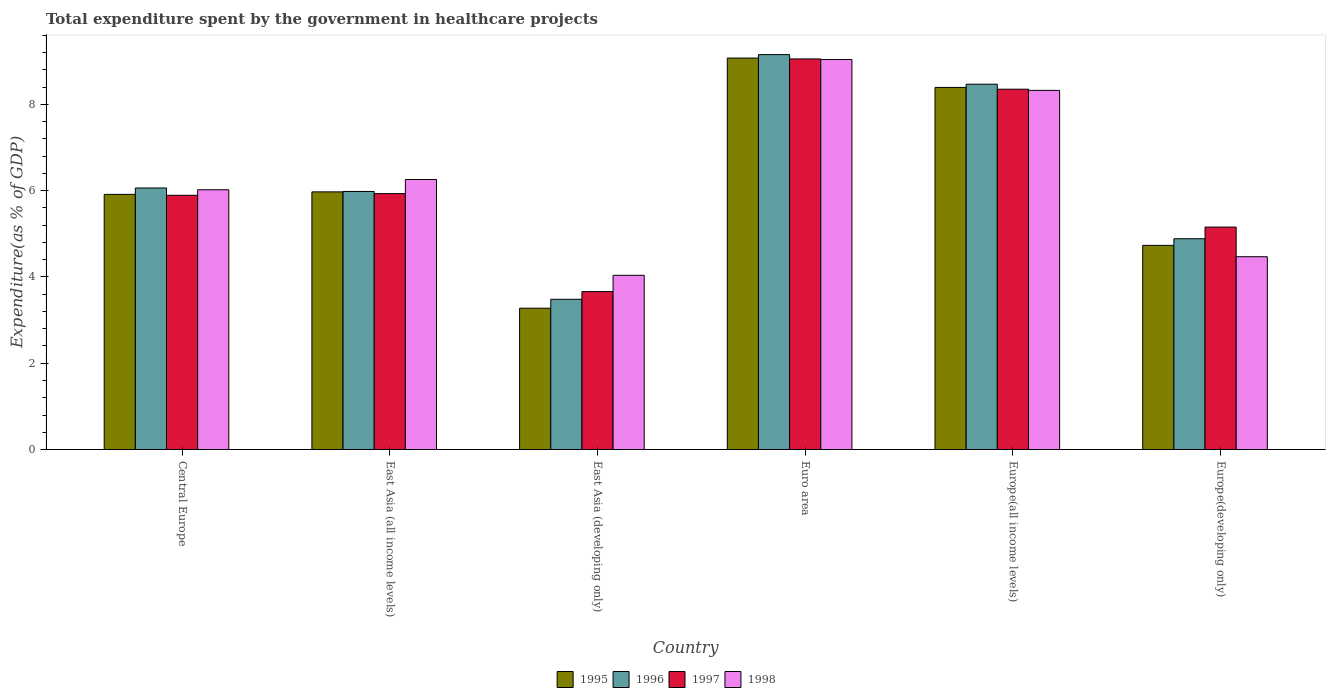Are the number of bars per tick equal to the number of legend labels?
Offer a very short reply. Yes. How many bars are there on the 3rd tick from the right?
Offer a very short reply. 4. What is the label of the 2nd group of bars from the left?
Offer a terse response. East Asia (all income levels). In how many cases, is the number of bars for a given country not equal to the number of legend labels?
Provide a succinct answer. 0. What is the total expenditure spent by the government in healthcare projects in 1995 in East Asia (all income levels)?
Offer a very short reply. 5.97. Across all countries, what is the maximum total expenditure spent by the government in healthcare projects in 1995?
Offer a very short reply. 9.08. Across all countries, what is the minimum total expenditure spent by the government in healthcare projects in 1998?
Offer a terse response. 4.04. In which country was the total expenditure spent by the government in healthcare projects in 1995 maximum?
Keep it short and to the point. Euro area. In which country was the total expenditure spent by the government in healthcare projects in 1996 minimum?
Provide a short and direct response. East Asia (developing only). What is the total total expenditure spent by the government in healthcare projects in 1998 in the graph?
Your answer should be compact. 38.16. What is the difference between the total expenditure spent by the government in healthcare projects in 1998 in Central Europe and that in Europe(developing only)?
Your answer should be compact. 1.55. What is the difference between the total expenditure spent by the government in healthcare projects in 1996 in East Asia (developing only) and the total expenditure spent by the government in healthcare projects in 1995 in East Asia (all income levels)?
Ensure brevity in your answer.  -2.49. What is the average total expenditure spent by the government in healthcare projects in 1995 per country?
Give a very brief answer. 6.23. What is the difference between the total expenditure spent by the government in healthcare projects of/in 1995 and total expenditure spent by the government in healthcare projects of/in 1997 in Euro area?
Keep it short and to the point. 0.02. What is the ratio of the total expenditure spent by the government in healthcare projects in 1996 in Central Europe to that in East Asia (all income levels)?
Keep it short and to the point. 1.01. What is the difference between the highest and the second highest total expenditure spent by the government in healthcare projects in 1996?
Give a very brief answer. -0.69. What is the difference between the highest and the lowest total expenditure spent by the government in healthcare projects in 1996?
Your response must be concise. 5.67. Is the sum of the total expenditure spent by the government in healthcare projects in 1998 in Euro area and Europe(developing only) greater than the maximum total expenditure spent by the government in healthcare projects in 1995 across all countries?
Provide a succinct answer. Yes. What does the 2nd bar from the left in East Asia (all income levels) represents?
Provide a short and direct response. 1996. What does the 3rd bar from the right in Euro area represents?
Provide a succinct answer. 1996. How many bars are there?
Keep it short and to the point. 24. Are all the bars in the graph horizontal?
Your response must be concise. No. What is the difference between two consecutive major ticks on the Y-axis?
Make the answer very short. 2. Does the graph contain grids?
Your answer should be compact. No. How many legend labels are there?
Your answer should be compact. 4. How are the legend labels stacked?
Your response must be concise. Horizontal. What is the title of the graph?
Ensure brevity in your answer.  Total expenditure spent by the government in healthcare projects. Does "1983" appear as one of the legend labels in the graph?
Offer a terse response. No. What is the label or title of the Y-axis?
Offer a terse response. Expenditure(as % of GDP). What is the Expenditure(as % of GDP) in 1995 in Central Europe?
Offer a very short reply. 5.92. What is the Expenditure(as % of GDP) of 1996 in Central Europe?
Offer a very short reply. 6.06. What is the Expenditure(as % of GDP) of 1997 in Central Europe?
Your answer should be compact. 5.89. What is the Expenditure(as % of GDP) of 1998 in Central Europe?
Make the answer very short. 6.02. What is the Expenditure(as % of GDP) of 1995 in East Asia (all income levels)?
Offer a terse response. 5.97. What is the Expenditure(as % of GDP) of 1996 in East Asia (all income levels)?
Give a very brief answer. 5.98. What is the Expenditure(as % of GDP) of 1997 in East Asia (all income levels)?
Your answer should be very brief. 5.93. What is the Expenditure(as % of GDP) in 1998 in East Asia (all income levels)?
Give a very brief answer. 6.26. What is the Expenditure(as % of GDP) in 1995 in East Asia (developing only)?
Provide a succinct answer. 3.28. What is the Expenditure(as % of GDP) of 1996 in East Asia (developing only)?
Provide a succinct answer. 3.48. What is the Expenditure(as % of GDP) of 1997 in East Asia (developing only)?
Offer a very short reply. 3.66. What is the Expenditure(as % of GDP) in 1998 in East Asia (developing only)?
Your answer should be very brief. 4.04. What is the Expenditure(as % of GDP) in 1995 in Euro area?
Make the answer very short. 9.08. What is the Expenditure(as % of GDP) of 1996 in Euro area?
Make the answer very short. 9.16. What is the Expenditure(as % of GDP) in 1997 in Euro area?
Provide a short and direct response. 9.06. What is the Expenditure(as % of GDP) in 1998 in Euro area?
Your answer should be compact. 9.04. What is the Expenditure(as % of GDP) of 1995 in Europe(all income levels)?
Your response must be concise. 8.39. What is the Expenditure(as % of GDP) in 1996 in Europe(all income levels)?
Offer a terse response. 8.47. What is the Expenditure(as % of GDP) in 1997 in Europe(all income levels)?
Your answer should be compact. 8.35. What is the Expenditure(as % of GDP) in 1998 in Europe(all income levels)?
Provide a short and direct response. 8.33. What is the Expenditure(as % of GDP) of 1995 in Europe(developing only)?
Ensure brevity in your answer.  4.73. What is the Expenditure(as % of GDP) in 1996 in Europe(developing only)?
Keep it short and to the point. 4.89. What is the Expenditure(as % of GDP) of 1997 in Europe(developing only)?
Make the answer very short. 5.16. What is the Expenditure(as % of GDP) of 1998 in Europe(developing only)?
Your response must be concise. 4.47. Across all countries, what is the maximum Expenditure(as % of GDP) in 1995?
Your answer should be very brief. 9.08. Across all countries, what is the maximum Expenditure(as % of GDP) in 1996?
Ensure brevity in your answer.  9.16. Across all countries, what is the maximum Expenditure(as % of GDP) in 1997?
Ensure brevity in your answer.  9.06. Across all countries, what is the maximum Expenditure(as % of GDP) of 1998?
Your response must be concise. 9.04. Across all countries, what is the minimum Expenditure(as % of GDP) in 1995?
Your answer should be compact. 3.28. Across all countries, what is the minimum Expenditure(as % of GDP) in 1996?
Keep it short and to the point. 3.48. Across all countries, what is the minimum Expenditure(as % of GDP) in 1997?
Your response must be concise. 3.66. Across all countries, what is the minimum Expenditure(as % of GDP) in 1998?
Your answer should be very brief. 4.04. What is the total Expenditure(as % of GDP) in 1995 in the graph?
Offer a very short reply. 37.37. What is the total Expenditure(as % of GDP) of 1996 in the graph?
Offer a terse response. 38.04. What is the total Expenditure(as % of GDP) in 1997 in the graph?
Your answer should be very brief. 38.05. What is the total Expenditure(as % of GDP) in 1998 in the graph?
Your answer should be compact. 38.16. What is the difference between the Expenditure(as % of GDP) of 1995 in Central Europe and that in East Asia (all income levels)?
Give a very brief answer. -0.06. What is the difference between the Expenditure(as % of GDP) in 1996 in Central Europe and that in East Asia (all income levels)?
Ensure brevity in your answer.  0.08. What is the difference between the Expenditure(as % of GDP) in 1997 in Central Europe and that in East Asia (all income levels)?
Offer a terse response. -0.04. What is the difference between the Expenditure(as % of GDP) in 1998 in Central Europe and that in East Asia (all income levels)?
Provide a succinct answer. -0.24. What is the difference between the Expenditure(as % of GDP) of 1995 in Central Europe and that in East Asia (developing only)?
Provide a short and direct response. 2.64. What is the difference between the Expenditure(as % of GDP) of 1996 in Central Europe and that in East Asia (developing only)?
Your answer should be compact. 2.58. What is the difference between the Expenditure(as % of GDP) in 1997 in Central Europe and that in East Asia (developing only)?
Offer a very short reply. 2.23. What is the difference between the Expenditure(as % of GDP) in 1998 in Central Europe and that in East Asia (developing only)?
Give a very brief answer. 1.98. What is the difference between the Expenditure(as % of GDP) in 1995 in Central Europe and that in Euro area?
Make the answer very short. -3.16. What is the difference between the Expenditure(as % of GDP) of 1996 in Central Europe and that in Euro area?
Your answer should be very brief. -3.09. What is the difference between the Expenditure(as % of GDP) of 1997 in Central Europe and that in Euro area?
Provide a succinct answer. -3.16. What is the difference between the Expenditure(as % of GDP) of 1998 in Central Europe and that in Euro area?
Make the answer very short. -3.02. What is the difference between the Expenditure(as % of GDP) in 1995 in Central Europe and that in Europe(all income levels)?
Make the answer very short. -2.48. What is the difference between the Expenditure(as % of GDP) in 1996 in Central Europe and that in Europe(all income levels)?
Offer a very short reply. -2.41. What is the difference between the Expenditure(as % of GDP) in 1997 in Central Europe and that in Europe(all income levels)?
Your response must be concise. -2.46. What is the difference between the Expenditure(as % of GDP) in 1998 in Central Europe and that in Europe(all income levels)?
Offer a very short reply. -2.3. What is the difference between the Expenditure(as % of GDP) in 1995 in Central Europe and that in Europe(developing only)?
Your response must be concise. 1.18. What is the difference between the Expenditure(as % of GDP) of 1996 in Central Europe and that in Europe(developing only)?
Offer a terse response. 1.18. What is the difference between the Expenditure(as % of GDP) of 1997 in Central Europe and that in Europe(developing only)?
Give a very brief answer. 0.74. What is the difference between the Expenditure(as % of GDP) of 1998 in Central Europe and that in Europe(developing only)?
Your answer should be very brief. 1.55. What is the difference between the Expenditure(as % of GDP) of 1995 in East Asia (all income levels) and that in East Asia (developing only)?
Your answer should be compact. 2.7. What is the difference between the Expenditure(as % of GDP) of 1996 in East Asia (all income levels) and that in East Asia (developing only)?
Offer a terse response. 2.5. What is the difference between the Expenditure(as % of GDP) in 1997 in East Asia (all income levels) and that in East Asia (developing only)?
Offer a terse response. 2.27. What is the difference between the Expenditure(as % of GDP) of 1998 in East Asia (all income levels) and that in East Asia (developing only)?
Ensure brevity in your answer.  2.22. What is the difference between the Expenditure(as % of GDP) of 1995 in East Asia (all income levels) and that in Euro area?
Your response must be concise. -3.1. What is the difference between the Expenditure(as % of GDP) of 1996 in East Asia (all income levels) and that in Euro area?
Offer a terse response. -3.17. What is the difference between the Expenditure(as % of GDP) of 1997 in East Asia (all income levels) and that in Euro area?
Ensure brevity in your answer.  -3.12. What is the difference between the Expenditure(as % of GDP) in 1998 in East Asia (all income levels) and that in Euro area?
Provide a short and direct response. -2.78. What is the difference between the Expenditure(as % of GDP) of 1995 in East Asia (all income levels) and that in Europe(all income levels)?
Offer a very short reply. -2.42. What is the difference between the Expenditure(as % of GDP) of 1996 in East Asia (all income levels) and that in Europe(all income levels)?
Offer a terse response. -2.49. What is the difference between the Expenditure(as % of GDP) in 1997 in East Asia (all income levels) and that in Europe(all income levels)?
Your answer should be compact. -2.42. What is the difference between the Expenditure(as % of GDP) of 1998 in East Asia (all income levels) and that in Europe(all income levels)?
Provide a succinct answer. -2.07. What is the difference between the Expenditure(as % of GDP) of 1995 in East Asia (all income levels) and that in Europe(developing only)?
Make the answer very short. 1.24. What is the difference between the Expenditure(as % of GDP) in 1996 in East Asia (all income levels) and that in Europe(developing only)?
Keep it short and to the point. 1.1. What is the difference between the Expenditure(as % of GDP) of 1997 in East Asia (all income levels) and that in Europe(developing only)?
Make the answer very short. 0.78. What is the difference between the Expenditure(as % of GDP) of 1998 in East Asia (all income levels) and that in Europe(developing only)?
Give a very brief answer. 1.79. What is the difference between the Expenditure(as % of GDP) in 1995 in East Asia (developing only) and that in Euro area?
Provide a short and direct response. -5.8. What is the difference between the Expenditure(as % of GDP) of 1996 in East Asia (developing only) and that in Euro area?
Give a very brief answer. -5.67. What is the difference between the Expenditure(as % of GDP) of 1997 in East Asia (developing only) and that in Euro area?
Ensure brevity in your answer.  -5.39. What is the difference between the Expenditure(as % of GDP) of 1998 in East Asia (developing only) and that in Euro area?
Your answer should be very brief. -5. What is the difference between the Expenditure(as % of GDP) in 1995 in East Asia (developing only) and that in Europe(all income levels)?
Provide a succinct answer. -5.12. What is the difference between the Expenditure(as % of GDP) of 1996 in East Asia (developing only) and that in Europe(all income levels)?
Make the answer very short. -4.99. What is the difference between the Expenditure(as % of GDP) of 1997 in East Asia (developing only) and that in Europe(all income levels)?
Provide a short and direct response. -4.69. What is the difference between the Expenditure(as % of GDP) of 1998 in East Asia (developing only) and that in Europe(all income levels)?
Offer a very short reply. -4.29. What is the difference between the Expenditure(as % of GDP) in 1995 in East Asia (developing only) and that in Europe(developing only)?
Give a very brief answer. -1.46. What is the difference between the Expenditure(as % of GDP) in 1996 in East Asia (developing only) and that in Europe(developing only)?
Your answer should be compact. -1.4. What is the difference between the Expenditure(as % of GDP) in 1997 in East Asia (developing only) and that in Europe(developing only)?
Offer a terse response. -1.5. What is the difference between the Expenditure(as % of GDP) of 1998 in East Asia (developing only) and that in Europe(developing only)?
Provide a succinct answer. -0.43. What is the difference between the Expenditure(as % of GDP) in 1995 in Euro area and that in Europe(all income levels)?
Offer a very short reply. 0.68. What is the difference between the Expenditure(as % of GDP) in 1996 in Euro area and that in Europe(all income levels)?
Ensure brevity in your answer.  0.69. What is the difference between the Expenditure(as % of GDP) of 1997 in Euro area and that in Europe(all income levels)?
Ensure brevity in your answer.  0.7. What is the difference between the Expenditure(as % of GDP) in 1998 in Euro area and that in Europe(all income levels)?
Offer a very short reply. 0.72. What is the difference between the Expenditure(as % of GDP) of 1995 in Euro area and that in Europe(developing only)?
Your answer should be very brief. 4.34. What is the difference between the Expenditure(as % of GDP) of 1996 in Euro area and that in Europe(developing only)?
Provide a short and direct response. 4.27. What is the difference between the Expenditure(as % of GDP) of 1997 in Euro area and that in Europe(developing only)?
Your answer should be very brief. 3.9. What is the difference between the Expenditure(as % of GDP) in 1998 in Euro area and that in Europe(developing only)?
Keep it short and to the point. 4.57. What is the difference between the Expenditure(as % of GDP) of 1995 in Europe(all income levels) and that in Europe(developing only)?
Give a very brief answer. 3.66. What is the difference between the Expenditure(as % of GDP) in 1996 in Europe(all income levels) and that in Europe(developing only)?
Your answer should be very brief. 3.58. What is the difference between the Expenditure(as % of GDP) of 1997 in Europe(all income levels) and that in Europe(developing only)?
Your answer should be compact. 3.2. What is the difference between the Expenditure(as % of GDP) of 1998 in Europe(all income levels) and that in Europe(developing only)?
Your answer should be compact. 3.86. What is the difference between the Expenditure(as % of GDP) of 1995 in Central Europe and the Expenditure(as % of GDP) of 1996 in East Asia (all income levels)?
Provide a succinct answer. -0.07. What is the difference between the Expenditure(as % of GDP) in 1995 in Central Europe and the Expenditure(as % of GDP) in 1997 in East Asia (all income levels)?
Offer a very short reply. -0.02. What is the difference between the Expenditure(as % of GDP) in 1995 in Central Europe and the Expenditure(as % of GDP) in 1998 in East Asia (all income levels)?
Offer a terse response. -0.34. What is the difference between the Expenditure(as % of GDP) in 1996 in Central Europe and the Expenditure(as % of GDP) in 1997 in East Asia (all income levels)?
Your answer should be compact. 0.13. What is the difference between the Expenditure(as % of GDP) of 1996 in Central Europe and the Expenditure(as % of GDP) of 1998 in East Asia (all income levels)?
Provide a short and direct response. -0.2. What is the difference between the Expenditure(as % of GDP) in 1997 in Central Europe and the Expenditure(as % of GDP) in 1998 in East Asia (all income levels)?
Offer a very short reply. -0.37. What is the difference between the Expenditure(as % of GDP) in 1995 in Central Europe and the Expenditure(as % of GDP) in 1996 in East Asia (developing only)?
Make the answer very short. 2.43. What is the difference between the Expenditure(as % of GDP) of 1995 in Central Europe and the Expenditure(as % of GDP) of 1997 in East Asia (developing only)?
Keep it short and to the point. 2.25. What is the difference between the Expenditure(as % of GDP) of 1995 in Central Europe and the Expenditure(as % of GDP) of 1998 in East Asia (developing only)?
Your response must be concise. 1.88. What is the difference between the Expenditure(as % of GDP) in 1996 in Central Europe and the Expenditure(as % of GDP) in 1997 in East Asia (developing only)?
Your answer should be very brief. 2.4. What is the difference between the Expenditure(as % of GDP) in 1996 in Central Europe and the Expenditure(as % of GDP) in 1998 in East Asia (developing only)?
Keep it short and to the point. 2.02. What is the difference between the Expenditure(as % of GDP) in 1997 in Central Europe and the Expenditure(as % of GDP) in 1998 in East Asia (developing only)?
Make the answer very short. 1.86. What is the difference between the Expenditure(as % of GDP) in 1995 in Central Europe and the Expenditure(as % of GDP) in 1996 in Euro area?
Your answer should be compact. -3.24. What is the difference between the Expenditure(as % of GDP) of 1995 in Central Europe and the Expenditure(as % of GDP) of 1997 in Euro area?
Provide a succinct answer. -3.14. What is the difference between the Expenditure(as % of GDP) in 1995 in Central Europe and the Expenditure(as % of GDP) in 1998 in Euro area?
Provide a short and direct response. -3.13. What is the difference between the Expenditure(as % of GDP) of 1996 in Central Europe and the Expenditure(as % of GDP) of 1997 in Euro area?
Your answer should be very brief. -2.99. What is the difference between the Expenditure(as % of GDP) of 1996 in Central Europe and the Expenditure(as % of GDP) of 1998 in Euro area?
Your answer should be compact. -2.98. What is the difference between the Expenditure(as % of GDP) in 1997 in Central Europe and the Expenditure(as % of GDP) in 1998 in Euro area?
Provide a short and direct response. -3.15. What is the difference between the Expenditure(as % of GDP) in 1995 in Central Europe and the Expenditure(as % of GDP) in 1996 in Europe(all income levels)?
Ensure brevity in your answer.  -2.55. What is the difference between the Expenditure(as % of GDP) of 1995 in Central Europe and the Expenditure(as % of GDP) of 1997 in Europe(all income levels)?
Provide a short and direct response. -2.44. What is the difference between the Expenditure(as % of GDP) in 1995 in Central Europe and the Expenditure(as % of GDP) in 1998 in Europe(all income levels)?
Ensure brevity in your answer.  -2.41. What is the difference between the Expenditure(as % of GDP) in 1996 in Central Europe and the Expenditure(as % of GDP) in 1997 in Europe(all income levels)?
Your answer should be compact. -2.29. What is the difference between the Expenditure(as % of GDP) of 1996 in Central Europe and the Expenditure(as % of GDP) of 1998 in Europe(all income levels)?
Make the answer very short. -2.26. What is the difference between the Expenditure(as % of GDP) of 1997 in Central Europe and the Expenditure(as % of GDP) of 1998 in Europe(all income levels)?
Keep it short and to the point. -2.43. What is the difference between the Expenditure(as % of GDP) in 1995 in Central Europe and the Expenditure(as % of GDP) in 1996 in Europe(developing only)?
Keep it short and to the point. 1.03. What is the difference between the Expenditure(as % of GDP) in 1995 in Central Europe and the Expenditure(as % of GDP) in 1997 in Europe(developing only)?
Keep it short and to the point. 0.76. What is the difference between the Expenditure(as % of GDP) of 1995 in Central Europe and the Expenditure(as % of GDP) of 1998 in Europe(developing only)?
Offer a terse response. 1.45. What is the difference between the Expenditure(as % of GDP) of 1996 in Central Europe and the Expenditure(as % of GDP) of 1997 in Europe(developing only)?
Keep it short and to the point. 0.91. What is the difference between the Expenditure(as % of GDP) of 1996 in Central Europe and the Expenditure(as % of GDP) of 1998 in Europe(developing only)?
Your answer should be very brief. 1.59. What is the difference between the Expenditure(as % of GDP) in 1997 in Central Europe and the Expenditure(as % of GDP) in 1998 in Europe(developing only)?
Offer a very short reply. 1.42. What is the difference between the Expenditure(as % of GDP) in 1995 in East Asia (all income levels) and the Expenditure(as % of GDP) in 1996 in East Asia (developing only)?
Ensure brevity in your answer.  2.49. What is the difference between the Expenditure(as % of GDP) in 1995 in East Asia (all income levels) and the Expenditure(as % of GDP) in 1997 in East Asia (developing only)?
Offer a terse response. 2.31. What is the difference between the Expenditure(as % of GDP) in 1995 in East Asia (all income levels) and the Expenditure(as % of GDP) in 1998 in East Asia (developing only)?
Provide a short and direct response. 1.93. What is the difference between the Expenditure(as % of GDP) of 1996 in East Asia (all income levels) and the Expenditure(as % of GDP) of 1997 in East Asia (developing only)?
Offer a terse response. 2.32. What is the difference between the Expenditure(as % of GDP) in 1996 in East Asia (all income levels) and the Expenditure(as % of GDP) in 1998 in East Asia (developing only)?
Make the answer very short. 1.94. What is the difference between the Expenditure(as % of GDP) in 1997 in East Asia (all income levels) and the Expenditure(as % of GDP) in 1998 in East Asia (developing only)?
Give a very brief answer. 1.89. What is the difference between the Expenditure(as % of GDP) in 1995 in East Asia (all income levels) and the Expenditure(as % of GDP) in 1996 in Euro area?
Provide a short and direct response. -3.18. What is the difference between the Expenditure(as % of GDP) in 1995 in East Asia (all income levels) and the Expenditure(as % of GDP) in 1997 in Euro area?
Make the answer very short. -3.08. What is the difference between the Expenditure(as % of GDP) in 1995 in East Asia (all income levels) and the Expenditure(as % of GDP) in 1998 in Euro area?
Offer a terse response. -3.07. What is the difference between the Expenditure(as % of GDP) of 1996 in East Asia (all income levels) and the Expenditure(as % of GDP) of 1997 in Euro area?
Provide a succinct answer. -3.07. What is the difference between the Expenditure(as % of GDP) in 1996 in East Asia (all income levels) and the Expenditure(as % of GDP) in 1998 in Euro area?
Provide a short and direct response. -3.06. What is the difference between the Expenditure(as % of GDP) of 1997 in East Asia (all income levels) and the Expenditure(as % of GDP) of 1998 in Euro area?
Make the answer very short. -3.11. What is the difference between the Expenditure(as % of GDP) in 1995 in East Asia (all income levels) and the Expenditure(as % of GDP) in 1996 in Europe(all income levels)?
Provide a succinct answer. -2.5. What is the difference between the Expenditure(as % of GDP) in 1995 in East Asia (all income levels) and the Expenditure(as % of GDP) in 1997 in Europe(all income levels)?
Ensure brevity in your answer.  -2.38. What is the difference between the Expenditure(as % of GDP) in 1995 in East Asia (all income levels) and the Expenditure(as % of GDP) in 1998 in Europe(all income levels)?
Give a very brief answer. -2.35. What is the difference between the Expenditure(as % of GDP) of 1996 in East Asia (all income levels) and the Expenditure(as % of GDP) of 1997 in Europe(all income levels)?
Offer a very short reply. -2.37. What is the difference between the Expenditure(as % of GDP) in 1996 in East Asia (all income levels) and the Expenditure(as % of GDP) in 1998 in Europe(all income levels)?
Offer a very short reply. -2.34. What is the difference between the Expenditure(as % of GDP) in 1997 in East Asia (all income levels) and the Expenditure(as % of GDP) in 1998 in Europe(all income levels)?
Make the answer very short. -2.39. What is the difference between the Expenditure(as % of GDP) in 1995 in East Asia (all income levels) and the Expenditure(as % of GDP) in 1996 in Europe(developing only)?
Give a very brief answer. 1.09. What is the difference between the Expenditure(as % of GDP) in 1995 in East Asia (all income levels) and the Expenditure(as % of GDP) in 1997 in Europe(developing only)?
Offer a very short reply. 0.82. What is the difference between the Expenditure(as % of GDP) of 1995 in East Asia (all income levels) and the Expenditure(as % of GDP) of 1998 in Europe(developing only)?
Ensure brevity in your answer.  1.5. What is the difference between the Expenditure(as % of GDP) in 1996 in East Asia (all income levels) and the Expenditure(as % of GDP) in 1997 in Europe(developing only)?
Your answer should be very brief. 0.83. What is the difference between the Expenditure(as % of GDP) in 1996 in East Asia (all income levels) and the Expenditure(as % of GDP) in 1998 in Europe(developing only)?
Offer a very short reply. 1.51. What is the difference between the Expenditure(as % of GDP) of 1997 in East Asia (all income levels) and the Expenditure(as % of GDP) of 1998 in Europe(developing only)?
Offer a very short reply. 1.46. What is the difference between the Expenditure(as % of GDP) in 1995 in East Asia (developing only) and the Expenditure(as % of GDP) in 1996 in Euro area?
Your response must be concise. -5.88. What is the difference between the Expenditure(as % of GDP) in 1995 in East Asia (developing only) and the Expenditure(as % of GDP) in 1997 in Euro area?
Provide a succinct answer. -5.78. What is the difference between the Expenditure(as % of GDP) in 1995 in East Asia (developing only) and the Expenditure(as % of GDP) in 1998 in Euro area?
Ensure brevity in your answer.  -5.77. What is the difference between the Expenditure(as % of GDP) of 1996 in East Asia (developing only) and the Expenditure(as % of GDP) of 1997 in Euro area?
Provide a short and direct response. -5.57. What is the difference between the Expenditure(as % of GDP) of 1996 in East Asia (developing only) and the Expenditure(as % of GDP) of 1998 in Euro area?
Provide a succinct answer. -5.56. What is the difference between the Expenditure(as % of GDP) in 1997 in East Asia (developing only) and the Expenditure(as % of GDP) in 1998 in Euro area?
Make the answer very short. -5.38. What is the difference between the Expenditure(as % of GDP) of 1995 in East Asia (developing only) and the Expenditure(as % of GDP) of 1996 in Europe(all income levels)?
Your answer should be very brief. -5.19. What is the difference between the Expenditure(as % of GDP) of 1995 in East Asia (developing only) and the Expenditure(as % of GDP) of 1997 in Europe(all income levels)?
Provide a succinct answer. -5.08. What is the difference between the Expenditure(as % of GDP) of 1995 in East Asia (developing only) and the Expenditure(as % of GDP) of 1998 in Europe(all income levels)?
Your response must be concise. -5.05. What is the difference between the Expenditure(as % of GDP) in 1996 in East Asia (developing only) and the Expenditure(as % of GDP) in 1997 in Europe(all income levels)?
Ensure brevity in your answer.  -4.87. What is the difference between the Expenditure(as % of GDP) of 1996 in East Asia (developing only) and the Expenditure(as % of GDP) of 1998 in Europe(all income levels)?
Your response must be concise. -4.84. What is the difference between the Expenditure(as % of GDP) in 1997 in East Asia (developing only) and the Expenditure(as % of GDP) in 1998 in Europe(all income levels)?
Ensure brevity in your answer.  -4.67. What is the difference between the Expenditure(as % of GDP) in 1995 in East Asia (developing only) and the Expenditure(as % of GDP) in 1996 in Europe(developing only)?
Ensure brevity in your answer.  -1.61. What is the difference between the Expenditure(as % of GDP) in 1995 in East Asia (developing only) and the Expenditure(as % of GDP) in 1997 in Europe(developing only)?
Provide a succinct answer. -1.88. What is the difference between the Expenditure(as % of GDP) in 1995 in East Asia (developing only) and the Expenditure(as % of GDP) in 1998 in Europe(developing only)?
Provide a short and direct response. -1.19. What is the difference between the Expenditure(as % of GDP) in 1996 in East Asia (developing only) and the Expenditure(as % of GDP) in 1997 in Europe(developing only)?
Offer a terse response. -1.67. What is the difference between the Expenditure(as % of GDP) of 1996 in East Asia (developing only) and the Expenditure(as % of GDP) of 1998 in Europe(developing only)?
Your answer should be very brief. -0.99. What is the difference between the Expenditure(as % of GDP) of 1997 in East Asia (developing only) and the Expenditure(as % of GDP) of 1998 in Europe(developing only)?
Provide a short and direct response. -0.81. What is the difference between the Expenditure(as % of GDP) in 1995 in Euro area and the Expenditure(as % of GDP) in 1996 in Europe(all income levels)?
Offer a terse response. 0.61. What is the difference between the Expenditure(as % of GDP) of 1995 in Euro area and the Expenditure(as % of GDP) of 1997 in Europe(all income levels)?
Provide a short and direct response. 0.72. What is the difference between the Expenditure(as % of GDP) in 1995 in Euro area and the Expenditure(as % of GDP) in 1998 in Europe(all income levels)?
Your response must be concise. 0.75. What is the difference between the Expenditure(as % of GDP) in 1996 in Euro area and the Expenditure(as % of GDP) in 1997 in Europe(all income levels)?
Make the answer very short. 0.8. What is the difference between the Expenditure(as % of GDP) in 1996 in Euro area and the Expenditure(as % of GDP) in 1998 in Europe(all income levels)?
Your answer should be compact. 0.83. What is the difference between the Expenditure(as % of GDP) of 1997 in Euro area and the Expenditure(as % of GDP) of 1998 in Europe(all income levels)?
Offer a terse response. 0.73. What is the difference between the Expenditure(as % of GDP) in 1995 in Euro area and the Expenditure(as % of GDP) in 1996 in Europe(developing only)?
Keep it short and to the point. 4.19. What is the difference between the Expenditure(as % of GDP) of 1995 in Euro area and the Expenditure(as % of GDP) of 1997 in Europe(developing only)?
Give a very brief answer. 3.92. What is the difference between the Expenditure(as % of GDP) in 1995 in Euro area and the Expenditure(as % of GDP) in 1998 in Europe(developing only)?
Your response must be concise. 4.61. What is the difference between the Expenditure(as % of GDP) of 1996 in Euro area and the Expenditure(as % of GDP) of 1997 in Europe(developing only)?
Your response must be concise. 4. What is the difference between the Expenditure(as % of GDP) in 1996 in Euro area and the Expenditure(as % of GDP) in 1998 in Europe(developing only)?
Ensure brevity in your answer.  4.69. What is the difference between the Expenditure(as % of GDP) of 1997 in Euro area and the Expenditure(as % of GDP) of 1998 in Europe(developing only)?
Provide a short and direct response. 4.59. What is the difference between the Expenditure(as % of GDP) of 1995 in Europe(all income levels) and the Expenditure(as % of GDP) of 1996 in Europe(developing only)?
Provide a succinct answer. 3.51. What is the difference between the Expenditure(as % of GDP) of 1995 in Europe(all income levels) and the Expenditure(as % of GDP) of 1997 in Europe(developing only)?
Your response must be concise. 3.24. What is the difference between the Expenditure(as % of GDP) of 1995 in Europe(all income levels) and the Expenditure(as % of GDP) of 1998 in Europe(developing only)?
Offer a terse response. 3.92. What is the difference between the Expenditure(as % of GDP) of 1996 in Europe(all income levels) and the Expenditure(as % of GDP) of 1997 in Europe(developing only)?
Offer a terse response. 3.31. What is the difference between the Expenditure(as % of GDP) of 1996 in Europe(all income levels) and the Expenditure(as % of GDP) of 1998 in Europe(developing only)?
Offer a terse response. 4. What is the difference between the Expenditure(as % of GDP) of 1997 in Europe(all income levels) and the Expenditure(as % of GDP) of 1998 in Europe(developing only)?
Your answer should be compact. 3.88. What is the average Expenditure(as % of GDP) in 1995 per country?
Your answer should be compact. 6.23. What is the average Expenditure(as % of GDP) of 1996 per country?
Offer a terse response. 6.34. What is the average Expenditure(as % of GDP) in 1997 per country?
Make the answer very short. 6.34. What is the average Expenditure(as % of GDP) of 1998 per country?
Make the answer very short. 6.36. What is the difference between the Expenditure(as % of GDP) in 1995 and Expenditure(as % of GDP) in 1996 in Central Europe?
Provide a short and direct response. -0.15. What is the difference between the Expenditure(as % of GDP) of 1995 and Expenditure(as % of GDP) of 1997 in Central Europe?
Give a very brief answer. 0.02. What is the difference between the Expenditure(as % of GDP) in 1995 and Expenditure(as % of GDP) in 1998 in Central Europe?
Provide a succinct answer. -0.11. What is the difference between the Expenditure(as % of GDP) of 1996 and Expenditure(as % of GDP) of 1997 in Central Europe?
Provide a succinct answer. 0.17. What is the difference between the Expenditure(as % of GDP) in 1996 and Expenditure(as % of GDP) in 1998 in Central Europe?
Your response must be concise. 0.04. What is the difference between the Expenditure(as % of GDP) in 1997 and Expenditure(as % of GDP) in 1998 in Central Europe?
Provide a short and direct response. -0.13. What is the difference between the Expenditure(as % of GDP) in 1995 and Expenditure(as % of GDP) in 1996 in East Asia (all income levels)?
Provide a succinct answer. -0.01. What is the difference between the Expenditure(as % of GDP) in 1995 and Expenditure(as % of GDP) in 1997 in East Asia (all income levels)?
Make the answer very short. 0.04. What is the difference between the Expenditure(as % of GDP) in 1995 and Expenditure(as % of GDP) in 1998 in East Asia (all income levels)?
Offer a terse response. -0.29. What is the difference between the Expenditure(as % of GDP) in 1996 and Expenditure(as % of GDP) in 1997 in East Asia (all income levels)?
Give a very brief answer. 0.05. What is the difference between the Expenditure(as % of GDP) of 1996 and Expenditure(as % of GDP) of 1998 in East Asia (all income levels)?
Give a very brief answer. -0.28. What is the difference between the Expenditure(as % of GDP) in 1997 and Expenditure(as % of GDP) in 1998 in East Asia (all income levels)?
Your answer should be very brief. -0.33. What is the difference between the Expenditure(as % of GDP) in 1995 and Expenditure(as % of GDP) in 1996 in East Asia (developing only)?
Your response must be concise. -0.21. What is the difference between the Expenditure(as % of GDP) in 1995 and Expenditure(as % of GDP) in 1997 in East Asia (developing only)?
Give a very brief answer. -0.38. What is the difference between the Expenditure(as % of GDP) in 1995 and Expenditure(as % of GDP) in 1998 in East Asia (developing only)?
Provide a succinct answer. -0.76. What is the difference between the Expenditure(as % of GDP) of 1996 and Expenditure(as % of GDP) of 1997 in East Asia (developing only)?
Your answer should be very brief. -0.18. What is the difference between the Expenditure(as % of GDP) of 1996 and Expenditure(as % of GDP) of 1998 in East Asia (developing only)?
Make the answer very short. -0.56. What is the difference between the Expenditure(as % of GDP) of 1997 and Expenditure(as % of GDP) of 1998 in East Asia (developing only)?
Provide a short and direct response. -0.38. What is the difference between the Expenditure(as % of GDP) of 1995 and Expenditure(as % of GDP) of 1996 in Euro area?
Your response must be concise. -0.08. What is the difference between the Expenditure(as % of GDP) of 1995 and Expenditure(as % of GDP) of 1997 in Euro area?
Provide a short and direct response. 0.02. What is the difference between the Expenditure(as % of GDP) of 1995 and Expenditure(as % of GDP) of 1998 in Euro area?
Your answer should be very brief. 0.03. What is the difference between the Expenditure(as % of GDP) of 1996 and Expenditure(as % of GDP) of 1997 in Euro area?
Offer a very short reply. 0.1. What is the difference between the Expenditure(as % of GDP) in 1996 and Expenditure(as % of GDP) in 1998 in Euro area?
Your answer should be compact. 0.11. What is the difference between the Expenditure(as % of GDP) of 1997 and Expenditure(as % of GDP) of 1998 in Euro area?
Make the answer very short. 0.01. What is the difference between the Expenditure(as % of GDP) of 1995 and Expenditure(as % of GDP) of 1996 in Europe(all income levels)?
Offer a very short reply. -0.07. What is the difference between the Expenditure(as % of GDP) of 1995 and Expenditure(as % of GDP) of 1997 in Europe(all income levels)?
Provide a short and direct response. 0.04. What is the difference between the Expenditure(as % of GDP) of 1995 and Expenditure(as % of GDP) of 1998 in Europe(all income levels)?
Keep it short and to the point. 0.07. What is the difference between the Expenditure(as % of GDP) of 1996 and Expenditure(as % of GDP) of 1997 in Europe(all income levels)?
Your answer should be very brief. 0.12. What is the difference between the Expenditure(as % of GDP) in 1996 and Expenditure(as % of GDP) in 1998 in Europe(all income levels)?
Offer a very short reply. 0.14. What is the difference between the Expenditure(as % of GDP) of 1997 and Expenditure(as % of GDP) of 1998 in Europe(all income levels)?
Offer a terse response. 0.03. What is the difference between the Expenditure(as % of GDP) in 1995 and Expenditure(as % of GDP) in 1996 in Europe(developing only)?
Ensure brevity in your answer.  -0.15. What is the difference between the Expenditure(as % of GDP) in 1995 and Expenditure(as % of GDP) in 1997 in Europe(developing only)?
Make the answer very short. -0.42. What is the difference between the Expenditure(as % of GDP) in 1995 and Expenditure(as % of GDP) in 1998 in Europe(developing only)?
Give a very brief answer. 0.26. What is the difference between the Expenditure(as % of GDP) of 1996 and Expenditure(as % of GDP) of 1997 in Europe(developing only)?
Make the answer very short. -0.27. What is the difference between the Expenditure(as % of GDP) of 1996 and Expenditure(as % of GDP) of 1998 in Europe(developing only)?
Give a very brief answer. 0.42. What is the difference between the Expenditure(as % of GDP) in 1997 and Expenditure(as % of GDP) in 1998 in Europe(developing only)?
Your answer should be compact. 0.69. What is the ratio of the Expenditure(as % of GDP) in 1995 in Central Europe to that in East Asia (all income levels)?
Provide a short and direct response. 0.99. What is the ratio of the Expenditure(as % of GDP) of 1996 in Central Europe to that in East Asia (all income levels)?
Provide a short and direct response. 1.01. What is the ratio of the Expenditure(as % of GDP) in 1998 in Central Europe to that in East Asia (all income levels)?
Keep it short and to the point. 0.96. What is the ratio of the Expenditure(as % of GDP) in 1995 in Central Europe to that in East Asia (developing only)?
Your answer should be compact. 1.81. What is the ratio of the Expenditure(as % of GDP) of 1996 in Central Europe to that in East Asia (developing only)?
Your answer should be compact. 1.74. What is the ratio of the Expenditure(as % of GDP) of 1997 in Central Europe to that in East Asia (developing only)?
Offer a terse response. 1.61. What is the ratio of the Expenditure(as % of GDP) in 1998 in Central Europe to that in East Asia (developing only)?
Your answer should be very brief. 1.49. What is the ratio of the Expenditure(as % of GDP) of 1995 in Central Europe to that in Euro area?
Give a very brief answer. 0.65. What is the ratio of the Expenditure(as % of GDP) of 1996 in Central Europe to that in Euro area?
Provide a succinct answer. 0.66. What is the ratio of the Expenditure(as % of GDP) of 1997 in Central Europe to that in Euro area?
Ensure brevity in your answer.  0.65. What is the ratio of the Expenditure(as % of GDP) in 1998 in Central Europe to that in Euro area?
Keep it short and to the point. 0.67. What is the ratio of the Expenditure(as % of GDP) of 1995 in Central Europe to that in Europe(all income levels)?
Provide a short and direct response. 0.7. What is the ratio of the Expenditure(as % of GDP) in 1996 in Central Europe to that in Europe(all income levels)?
Keep it short and to the point. 0.72. What is the ratio of the Expenditure(as % of GDP) of 1997 in Central Europe to that in Europe(all income levels)?
Your answer should be very brief. 0.71. What is the ratio of the Expenditure(as % of GDP) in 1998 in Central Europe to that in Europe(all income levels)?
Offer a terse response. 0.72. What is the ratio of the Expenditure(as % of GDP) of 1995 in Central Europe to that in Europe(developing only)?
Keep it short and to the point. 1.25. What is the ratio of the Expenditure(as % of GDP) in 1996 in Central Europe to that in Europe(developing only)?
Your answer should be compact. 1.24. What is the ratio of the Expenditure(as % of GDP) in 1997 in Central Europe to that in Europe(developing only)?
Offer a terse response. 1.14. What is the ratio of the Expenditure(as % of GDP) of 1998 in Central Europe to that in Europe(developing only)?
Give a very brief answer. 1.35. What is the ratio of the Expenditure(as % of GDP) in 1995 in East Asia (all income levels) to that in East Asia (developing only)?
Offer a terse response. 1.82. What is the ratio of the Expenditure(as % of GDP) in 1996 in East Asia (all income levels) to that in East Asia (developing only)?
Give a very brief answer. 1.72. What is the ratio of the Expenditure(as % of GDP) in 1997 in East Asia (all income levels) to that in East Asia (developing only)?
Make the answer very short. 1.62. What is the ratio of the Expenditure(as % of GDP) of 1998 in East Asia (all income levels) to that in East Asia (developing only)?
Provide a succinct answer. 1.55. What is the ratio of the Expenditure(as % of GDP) of 1995 in East Asia (all income levels) to that in Euro area?
Make the answer very short. 0.66. What is the ratio of the Expenditure(as % of GDP) in 1996 in East Asia (all income levels) to that in Euro area?
Ensure brevity in your answer.  0.65. What is the ratio of the Expenditure(as % of GDP) of 1997 in East Asia (all income levels) to that in Euro area?
Provide a short and direct response. 0.66. What is the ratio of the Expenditure(as % of GDP) of 1998 in East Asia (all income levels) to that in Euro area?
Offer a terse response. 0.69. What is the ratio of the Expenditure(as % of GDP) in 1995 in East Asia (all income levels) to that in Europe(all income levels)?
Provide a short and direct response. 0.71. What is the ratio of the Expenditure(as % of GDP) in 1996 in East Asia (all income levels) to that in Europe(all income levels)?
Provide a short and direct response. 0.71. What is the ratio of the Expenditure(as % of GDP) of 1997 in East Asia (all income levels) to that in Europe(all income levels)?
Your answer should be compact. 0.71. What is the ratio of the Expenditure(as % of GDP) in 1998 in East Asia (all income levels) to that in Europe(all income levels)?
Provide a short and direct response. 0.75. What is the ratio of the Expenditure(as % of GDP) of 1995 in East Asia (all income levels) to that in Europe(developing only)?
Provide a succinct answer. 1.26. What is the ratio of the Expenditure(as % of GDP) in 1996 in East Asia (all income levels) to that in Europe(developing only)?
Your answer should be compact. 1.22. What is the ratio of the Expenditure(as % of GDP) of 1997 in East Asia (all income levels) to that in Europe(developing only)?
Offer a terse response. 1.15. What is the ratio of the Expenditure(as % of GDP) in 1998 in East Asia (all income levels) to that in Europe(developing only)?
Provide a short and direct response. 1.4. What is the ratio of the Expenditure(as % of GDP) of 1995 in East Asia (developing only) to that in Euro area?
Make the answer very short. 0.36. What is the ratio of the Expenditure(as % of GDP) of 1996 in East Asia (developing only) to that in Euro area?
Provide a succinct answer. 0.38. What is the ratio of the Expenditure(as % of GDP) of 1997 in East Asia (developing only) to that in Euro area?
Keep it short and to the point. 0.4. What is the ratio of the Expenditure(as % of GDP) in 1998 in East Asia (developing only) to that in Euro area?
Provide a succinct answer. 0.45. What is the ratio of the Expenditure(as % of GDP) of 1995 in East Asia (developing only) to that in Europe(all income levels)?
Provide a short and direct response. 0.39. What is the ratio of the Expenditure(as % of GDP) in 1996 in East Asia (developing only) to that in Europe(all income levels)?
Offer a very short reply. 0.41. What is the ratio of the Expenditure(as % of GDP) of 1997 in East Asia (developing only) to that in Europe(all income levels)?
Your answer should be very brief. 0.44. What is the ratio of the Expenditure(as % of GDP) in 1998 in East Asia (developing only) to that in Europe(all income levels)?
Provide a short and direct response. 0.49. What is the ratio of the Expenditure(as % of GDP) of 1995 in East Asia (developing only) to that in Europe(developing only)?
Offer a terse response. 0.69. What is the ratio of the Expenditure(as % of GDP) of 1996 in East Asia (developing only) to that in Europe(developing only)?
Your response must be concise. 0.71. What is the ratio of the Expenditure(as % of GDP) in 1997 in East Asia (developing only) to that in Europe(developing only)?
Keep it short and to the point. 0.71. What is the ratio of the Expenditure(as % of GDP) of 1998 in East Asia (developing only) to that in Europe(developing only)?
Give a very brief answer. 0.9. What is the ratio of the Expenditure(as % of GDP) of 1995 in Euro area to that in Europe(all income levels)?
Your answer should be compact. 1.08. What is the ratio of the Expenditure(as % of GDP) of 1996 in Euro area to that in Europe(all income levels)?
Provide a short and direct response. 1.08. What is the ratio of the Expenditure(as % of GDP) of 1997 in Euro area to that in Europe(all income levels)?
Offer a very short reply. 1.08. What is the ratio of the Expenditure(as % of GDP) of 1998 in Euro area to that in Europe(all income levels)?
Offer a terse response. 1.09. What is the ratio of the Expenditure(as % of GDP) of 1995 in Euro area to that in Europe(developing only)?
Your response must be concise. 1.92. What is the ratio of the Expenditure(as % of GDP) of 1996 in Euro area to that in Europe(developing only)?
Offer a terse response. 1.87. What is the ratio of the Expenditure(as % of GDP) of 1997 in Euro area to that in Europe(developing only)?
Provide a succinct answer. 1.76. What is the ratio of the Expenditure(as % of GDP) of 1998 in Euro area to that in Europe(developing only)?
Keep it short and to the point. 2.02. What is the ratio of the Expenditure(as % of GDP) in 1995 in Europe(all income levels) to that in Europe(developing only)?
Provide a succinct answer. 1.77. What is the ratio of the Expenditure(as % of GDP) in 1996 in Europe(all income levels) to that in Europe(developing only)?
Your answer should be very brief. 1.73. What is the ratio of the Expenditure(as % of GDP) in 1997 in Europe(all income levels) to that in Europe(developing only)?
Ensure brevity in your answer.  1.62. What is the ratio of the Expenditure(as % of GDP) in 1998 in Europe(all income levels) to that in Europe(developing only)?
Keep it short and to the point. 1.86. What is the difference between the highest and the second highest Expenditure(as % of GDP) of 1995?
Your response must be concise. 0.68. What is the difference between the highest and the second highest Expenditure(as % of GDP) in 1996?
Provide a succinct answer. 0.69. What is the difference between the highest and the second highest Expenditure(as % of GDP) of 1997?
Your answer should be very brief. 0.7. What is the difference between the highest and the second highest Expenditure(as % of GDP) of 1998?
Provide a succinct answer. 0.72. What is the difference between the highest and the lowest Expenditure(as % of GDP) in 1995?
Your answer should be very brief. 5.8. What is the difference between the highest and the lowest Expenditure(as % of GDP) in 1996?
Your answer should be compact. 5.67. What is the difference between the highest and the lowest Expenditure(as % of GDP) in 1997?
Offer a very short reply. 5.39. What is the difference between the highest and the lowest Expenditure(as % of GDP) of 1998?
Make the answer very short. 5. 